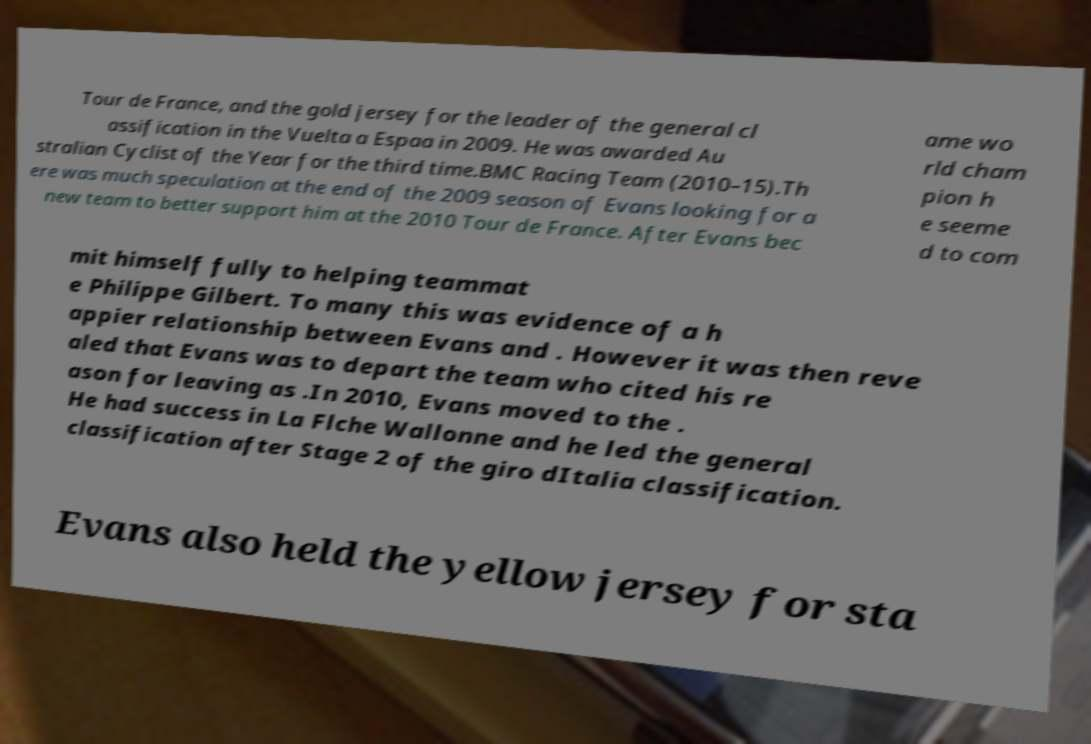I need the written content from this picture converted into text. Can you do that? Tour de France, and the gold jersey for the leader of the general cl assification in the Vuelta a Espaa in 2009. He was awarded Au stralian Cyclist of the Year for the third time.BMC Racing Team (2010–15).Th ere was much speculation at the end of the 2009 season of Evans looking for a new team to better support him at the 2010 Tour de France. After Evans bec ame wo rld cham pion h e seeme d to com mit himself fully to helping teammat e Philippe Gilbert. To many this was evidence of a h appier relationship between Evans and . However it was then reve aled that Evans was to depart the team who cited his re ason for leaving as .In 2010, Evans moved to the . He had success in La Flche Wallonne and he led the general classification after Stage 2 of the giro dItalia classification. Evans also held the yellow jersey for sta 